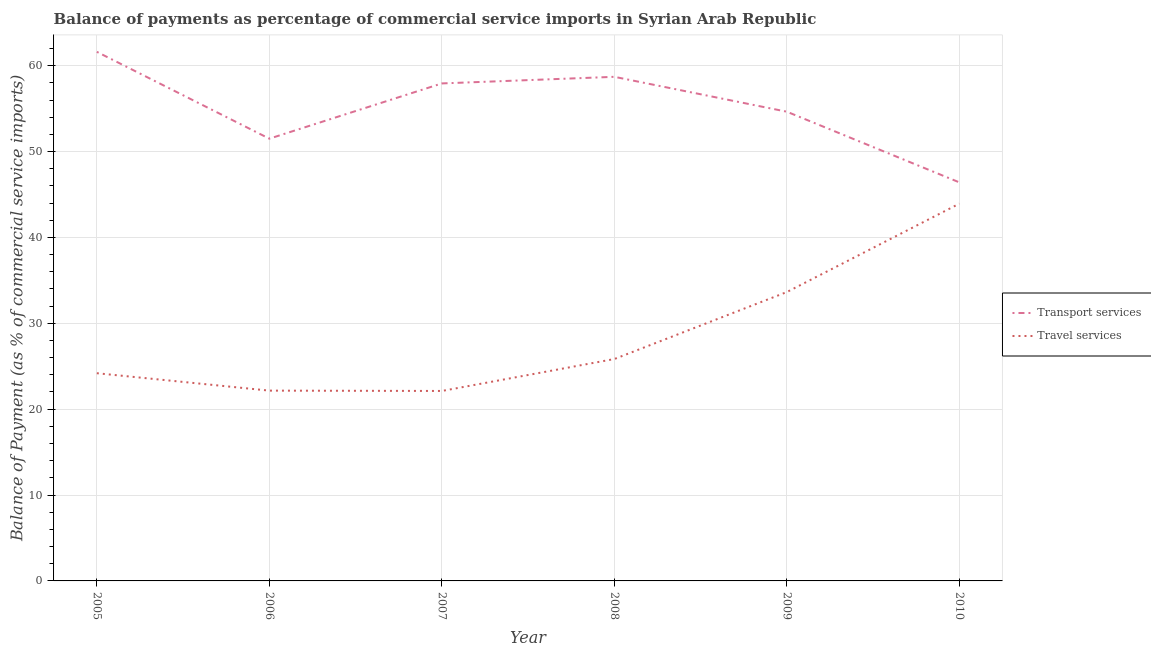How many different coloured lines are there?
Ensure brevity in your answer.  2. Does the line corresponding to balance of payments of transport services intersect with the line corresponding to balance of payments of travel services?
Provide a short and direct response. No. Is the number of lines equal to the number of legend labels?
Give a very brief answer. Yes. What is the balance of payments of transport services in 2009?
Keep it short and to the point. 54.64. Across all years, what is the maximum balance of payments of transport services?
Provide a short and direct response. 61.61. Across all years, what is the minimum balance of payments of travel services?
Your answer should be compact. 22.12. What is the total balance of payments of travel services in the graph?
Provide a succinct answer. 171.87. What is the difference between the balance of payments of transport services in 2006 and that in 2009?
Provide a short and direct response. -3.14. What is the difference between the balance of payments of travel services in 2008 and the balance of payments of transport services in 2005?
Offer a terse response. -35.77. What is the average balance of payments of travel services per year?
Your response must be concise. 28.65. In the year 2010, what is the difference between the balance of payments of transport services and balance of payments of travel services?
Provide a succinct answer. 2.48. In how many years, is the balance of payments of travel services greater than 48 %?
Your response must be concise. 0. What is the ratio of the balance of payments of transport services in 2007 to that in 2009?
Offer a terse response. 1.06. What is the difference between the highest and the second highest balance of payments of travel services?
Your answer should be very brief. 10.29. What is the difference between the highest and the lowest balance of payments of travel services?
Your answer should be compact. 21.81. Is the sum of the balance of payments of travel services in 2008 and 2009 greater than the maximum balance of payments of transport services across all years?
Your response must be concise. No. Does the balance of payments of transport services monotonically increase over the years?
Your answer should be very brief. No. Is the balance of payments of transport services strictly greater than the balance of payments of travel services over the years?
Keep it short and to the point. Yes. How many lines are there?
Provide a short and direct response. 2. How many years are there in the graph?
Your answer should be very brief. 6. Are the values on the major ticks of Y-axis written in scientific E-notation?
Provide a succinct answer. No. What is the title of the graph?
Your answer should be very brief. Balance of payments as percentage of commercial service imports in Syrian Arab Republic. What is the label or title of the Y-axis?
Make the answer very short. Balance of Payment (as % of commercial service imports). What is the Balance of Payment (as % of commercial service imports) of Transport services in 2005?
Provide a succinct answer. 61.61. What is the Balance of Payment (as % of commercial service imports) of Travel services in 2005?
Offer a terse response. 24.19. What is the Balance of Payment (as % of commercial service imports) in Transport services in 2006?
Ensure brevity in your answer.  51.5. What is the Balance of Payment (as % of commercial service imports) of Travel services in 2006?
Provide a short and direct response. 22.16. What is the Balance of Payment (as % of commercial service imports) of Transport services in 2007?
Ensure brevity in your answer.  57.93. What is the Balance of Payment (as % of commercial service imports) of Travel services in 2007?
Provide a succinct answer. 22.12. What is the Balance of Payment (as % of commercial service imports) of Transport services in 2008?
Your answer should be compact. 58.7. What is the Balance of Payment (as % of commercial service imports) in Travel services in 2008?
Offer a terse response. 25.84. What is the Balance of Payment (as % of commercial service imports) of Transport services in 2009?
Provide a short and direct response. 54.64. What is the Balance of Payment (as % of commercial service imports) in Travel services in 2009?
Keep it short and to the point. 33.64. What is the Balance of Payment (as % of commercial service imports) of Transport services in 2010?
Ensure brevity in your answer.  46.41. What is the Balance of Payment (as % of commercial service imports) in Travel services in 2010?
Provide a succinct answer. 43.93. Across all years, what is the maximum Balance of Payment (as % of commercial service imports) in Transport services?
Provide a succinct answer. 61.61. Across all years, what is the maximum Balance of Payment (as % of commercial service imports) in Travel services?
Ensure brevity in your answer.  43.93. Across all years, what is the minimum Balance of Payment (as % of commercial service imports) in Transport services?
Your answer should be compact. 46.41. Across all years, what is the minimum Balance of Payment (as % of commercial service imports) of Travel services?
Your answer should be compact. 22.12. What is the total Balance of Payment (as % of commercial service imports) in Transport services in the graph?
Give a very brief answer. 330.79. What is the total Balance of Payment (as % of commercial service imports) of Travel services in the graph?
Your answer should be very brief. 171.87. What is the difference between the Balance of Payment (as % of commercial service imports) in Transport services in 2005 and that in 2006?
Your response must be concise. 10.11. What is the difference between the Balance of Payment (as % of commercial service imports) of Travel services in 2005 and that in 2006?
Your answer should be compact. 2.03. What is the difference between the Balance of Payment (as % of commercial service imports) of Transport services in 2005 and that in 2007?
Offer a very short reply. 3.68. What is the difference between the Balance of Payment (as % of commercial service imports) in Travel services in 2005 and that in 2007?
Keep it short and to the point. 2.07. What is the difference between the Balance of Payment (as % of commercial service imports) in Transport services in 2005 and that in 2008?
Give a very brief answer. 2.91. What is the difference between the Balance of Payment (as % of commercial service imports) in Travel services in 2005 and that in 2008?
Provide a succinct answer. -1.65. What is the difference between the Balance of Payment (as % of commercial service imports) of Transport services in 2005 and that in 2009?
Provide a succinct answer. 6.97. What is the difference between the Balance of Payment (as % of commercial service imports) of Travel services in 2005 and that in 2009?
Your answer should be compact. -9.45. What is the difference between the Balance of Payment (as % of commercial service imports) of Transport services in 2005 and that in 2010?
Offer a terse response. 15.2. What is the difference between the Balance of Payment (as % of commercial service imports) of Travel services in 2005 and that in 2010?
Your response must be concise. -19.74. What is the difference between the Balance of Payment (as % of commercial service imports) of Transport services in 2006 and that in 2007?
Ensure brevity in your answer.  -6.43. What is the difference between the Balance of Payment (as % of commercial service imports) of Travel services in 2006 and that in 2007?
Provide a short and direct response. 0.04. What is the difference between the Balance of Payment (as % of commercial service imports) in Transport services in 2006 and that in 2008?
Ensure brevity in your answer.  -7.2. What is the difference between the Balance of Payment (as % of commercial service imports) of Travel services in 2006 and that in 2008?
Provide a succinct answer. -3.68. What is the difference between the Balance of Payment (as % of commercial service imports) of Transport services in 2006 and that in 2009?
Your answer should be very brief. -3.14. What is the difference between the Balance of Payment (as % of commercial service imports) of Travel services in 2006 and that in 2009?
Keep it short and to the point. -11.48. What is the difference between the Balance of Payment (as % of commercial service imports) of Transport services in 2006 and that in 2010?
Your response must be concise. 5.09. What is the difference between the Balance of Payment (as % of commercial service imports) of Travel services in 2006 and that in 2010?
Make the answer very short. -21.77. What is the difference between the Balance of Payment (as % of commercial service imports) in Transport services in 2007 and that in 2008?
Your answer should be very brief. -0.77. What is the difference between the Balance of Payment (as % of commercial service imports) of Travel services in 2007 and that in 2008?
Give a very brief answer. -3.72. What is the difference between the Balance of Payment (as % of commercial service imports) of Transport services in 2007 and that in 2009?
Keep it short and to the point. 3.29. What is the difference between the Balance of Payment (as % of commercial service imports) of Travel services in 2007 and that in 2009?
Make the answer very short. -11.52. What is the difference between the Balance of Payment (as % of commercial service imports) of Transport services in 2007 and that in 2010?
Provide a succinct answer. 11.52. What is the difference between the Balance of Payment (as % of commercial service imports) of Travel services in 2007 and that in 2010?
Keep it short and to the point. -21.81. What is the difference between the Balance of Payment (as % of commercial service imports) in Transport services in 2008 and that in 2009?
Give a very brief answer. 4.06. What is the difference between the Balance of Payment (as % of commercial service imports) of Travel services in 2008 and that in 2009?
Provide a succinct answer. -7.8. What is the difference between the Balance of Payment (as % of commercial service imports) in Transport services in 2008 and that in 2010?
Ensure brevity in your answer.  12.29. What is the difference between the Balance of Payment (as % of commercial service imports) of Travel services in 2008 and that in 2010?
Keep it short and to the point. -18.09. What is the difference between the Balance of Payment (as % of commercial service imports) in Transport services in 2009 and that in 2010?
Your answer should be compact. 8.23. What is the difference between the Balance of Payment (as % of commercial service imports) of Travel services in 2009 and that in 2010?
Your response must be concise. -10.29. What is the difference between the Balance of Payment (as % of commercial service imports) in Transport services in 2005 and the Balance of Payment (as % of commercial service imports) in Travel services in 2006?
Your answer should be compact. 39.45. What is the difference between the Balance of Payment (as % of commercial service imports) in Transport services in 2005 and the Balance of Payment (as % of commercial service imports) in Travel services in 2007?
Your response must be concise. 39.49. What is the difference between the Balance of Payment (as % of commercial service imports) of Transport services in 2005 and the Balance of Payment (as % of commercial service imports) of Travel services in 2008?
Offer a terse response. 35.77. What is the difference between the Balance of Payment (as % of commercial service imports) of Transport services in 2005 and the Balance of Payment (as % of commercial service imports) of Travel services in 2009?
Your answer should be compact. 27.97. What is the difference between the Balance of Payment (as % of commercial service imports) in Transport services in 2005 and the Balance of Payment (as % of commercial service imports) in Travel services in 2010?
Give a very brief answer. 17.68. What is the difference between the Balance of Payment (as % of commercial service imports) in Transport services in 2006 and the Balance of Payment (as % of commercial service imports) in Travel services in 2007?
Give a very brief answer. 29.38. What is the difference between the Balance of Payment (as % of commercial service imports) of Transport services in 2006 and the Balance of Payment (as % of commercial service imports) of Travel services in 2008?
Your answer should be compact. 25.66. What is the difference between the Balance of Payment (as % of commercial service imports) of Transport services in 2006 and the Balance of Payment (as % of commercial service imports) of Travel services in 2009?
Give a very brief answer. 17.86. What is the difference between the Balance of Payment (as % of commercial service imports) of Transport services in 2006 and the Balance of Payment (as % of commercial service imports) of Travel services in 2010?
Ensure brevity in your answer.  7.57. What is the difference between the Balance of Payment (as % of commercial service imports) of Transport services in 2007 and the Balance of Payment (as % of commercial service imports) of Travel services in 2008?
Your response must be concise. 32.09. What is the difference between the Balance of Payment (as % of commercial service imports) of Transport services in 2007 and the Balance of Payment (as % of commercial service imports) of Travel services in 2009?
Offer a terse response. 24.29. What is the difference between the Balance of Payment (as % of commercial service imports) of Transport services in 2007 and the Balance of Payment (as % of commercial service imports) of Travel services in 2010?
Provide a short and direct response. 14. What is the difference between the Balance of Payment (as % of commercial service imports) in Transport services in 2008 and the Balance of Payment (as % of commercial service imports) in Travel services in 2009?
Provide a succinct answer. 25.06. What is the difference between the Balance of Payment (as % of commercial service imports) in Transport services in 2008 and the Balance of Payment (as % of commercial service imports) in Travel services in 2010?
Give a very brief answer. 14.77. What is the difference between the Balance of Payment (as % of commercial service imports) in Transport services in 2009 and the Balance of Payment (as % of commercial service imports) in Travel services in 2010?
Give a very brief answer. 10.71. What is the average Balance of Payment (as % of commercial service imports) of Transport services per year?
Give a very brief answer. 55.13. What is the average Balance of Payment (as % of commercial service imports) in Travel services per year?
Provide a short and direct response. 28.65. In the year 2005, what is the difference between the Balance of Payment (as % of commercial service imports) in Transport services and Balance of Payment (as % of commercial service imports) in Travel services?
Your answer should be very brief. 37.42. In the year 2006, what is the difference between the Balance of Payment (as % of commercial service imports) of Transport services and Balance of Payment (as % of commercial service imports) of Travel services?
Your response must be concise. 29.34. In the year 2007, what is the difference between the Balance of Payment (as % of commercial service imports) in Transport services and Balance of Payment (as % of commercial service imports) in Travel services?
Give a very brief answer. 35.81. In the year 2008, what is the difference between the Balance of Payment (as % of commercial service imports) of Transport services and Balance of Payment (as % of commercial service imports) of Travel services?
Your answer should be compact. 32.86. In the year 2010, what is the difference between the Balance of Payment (as % of commercial service imports) in Transport services and Balance of Payment (as % of commercial service imports) in Travel services?
Ensure brevity in your answer.  2.48. What is the ratio of the Balance of Payment (as % of commercial service imports) in Transport services in 2005 to that in 2006?
Provide a succinct answer. 1.2. What is the ratio of the Balance of Payment (as % of commercial service imports) in Travel services in 2005 to that in 2006?
Your response must be concise. 1.09. What is the ratio of the Balance of Payment (as % of commercial service imports) in Transport services in 2005 to that in 2007?
Make the answer very short. 1.06. What is the ratio of the Balance of Payment (as % of commercial service imports) in Travel services in 2005 to that in 2007?
Give a very brief answer. 1.09. What is the ratio of the Balance of Payment (as % of commercial service imports) in Transport services in 2005 to that in 2008?
Your answer should be very brief. 1.05. What is the ratio of the Balance of Payment (as % of commercial service imports) of Travel services in 2005 to that in 2008?
Make the answer very short. 0.94. What is the ratio of the Balance of Payment (as % of commercial service imports) in Transport services in 2005 to that in 2009?
Your answer should be very brief. 1.13. What is the ratio of the Balance of Payment (as % of commercial service imports) of Travel services in 2005 to that in 2009?
Ensure brevity in your answer.  0.72. What is the ratio of the Balance of Payment (as % of commercial service imports) in Transport services in 2005 to that in 2010?
Your response must be concise. 1.33. What is the ratio of the Balance of Payment (as % of commercial service imports) of Travel services in 2005 to that in 2010?
Your answer should be compact. 0.55. What is the ratio of the Balance of Payment (as % of commercial service imports) in Transport services in 2006 to that in 2007?
Your response must be concise. 0.89. What is the ratio of the Balance of Payment (as % of commercial service imports) of Transport services in 2006 to that in 2008?
Make the answer very short. 0.88. What is the ratio of the Balance of Payment (as % of commercial service imports) of Travel services in 2006 to that in 2008?
Offer a very short reply. 0.86. What is the ratio of the Balance of Payment (as % of commercial service imports) in Transport services in 2006 to that in 2009?
Provide a short and direct response. 0.94. What is the ratio of the Balance of Payment (as % of commercial service imports) in Travel services in 2006 to that in 2009?
Your answer should be compact. 0.66. What is the ratio of the Balance of Payment (as % of commercial service imports) in Transport services in 2006 to that in 2010?
Make the answer very short. 1.11. What is the ratio of the Balance of Payment (as % of commercial service imports) of Travel services in 2006 to that in 2010?
Your response must be concise. 0.5. What is the ratio of the Balance of Payment (as % of commercial service imports) in Transport services in 2007 to that in 2008?
Offer a very short reply. 0.99. What is the ratio of the Balance of Payment (as % of commercial service imports) of Travel services in 2007 to that in 2008?
Offer a very short reply. 0.86. What is the ratio of the Balance of Payment (as % of commercial service imports) of Transport services in 2007 to that in 2009?
Your response must be concise. 1.06. What is the ratio of the Balance of Payment (as % of commercial service imports) of Travel services in 2007 to that in 2009?
Make the answer very short. 0.66. What is the ratio of the Balance of Payment (as % of commercial service imports) in Transport services in 2007 to that in 2010?
Your answer should be very brief. 1.25. What is the ratio of the Balance of Payment (as % of commercial service imports) in Travel services in 2007 to that in 2010?
Keep it short and to the point. 0.5. What is the ratio of the Balance of Payment (as % of commercial service imports) in Transport services in 2008 to that in 2009?
Offer a terse response. 1.07. What is the ratio of the Balance of Payment (as % of commercial service imports) in Travel services in 2008 to that in 2009?
Your response must be concise. 0.77. What is the ratio of the Balance of Payment (as % of commercial service imports) of Transport services in 2008 to that in 2010?
Your response must be concise. 1.26. What is the ratio of the Balance of Payment (as % of commercial service imports) of Travel services in 2008 to that in 2010?
Offer a very short reply. 0.59. What is the ratio of the Balance of Payment (as % of commercial service imports) of Transport services in 2009 to that in 2010?
Ensure brevity in your answer.  1.18. What is the ratio of the Balance of Payment (as % of commercial service imports) in Travel services in 2009 to that in 2010?
Provide a short and direct response. 0.77. What is the difference between the highest and the second highest Balance of Payment (as % of commercial service imports) in Transport services?
Provide a succinct answer. 2.91. What is the difference between the highest and the second highest Balance of Payment (as % of commercial service imports) in Travel services?
Your response must be concise. 10.29. What is the difference between the highest and the lowest Balance of Payment (as % of commercial service imports) of Transport services?
Keep it short and to the point. 15.2. What is the difference between the highest and the lowest Balance of Payment (as % of commercial service imports) in Travel services?
Keep it short and to the point. 21.81. 